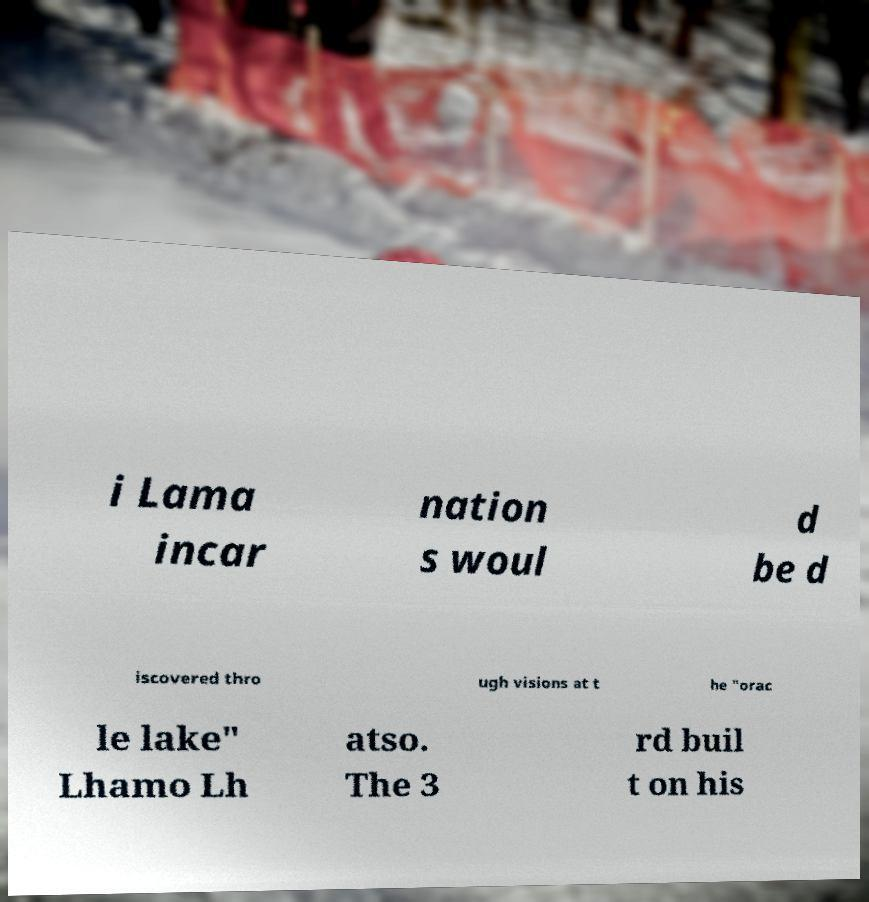What messages or text are displayed in this image? I need them in a readable, typed format. i Lama incar nation s woul d be d iscovered thro ugh visions at t he "orac le lake" Lhamo Lh atso. The 3 rd buil t on his 